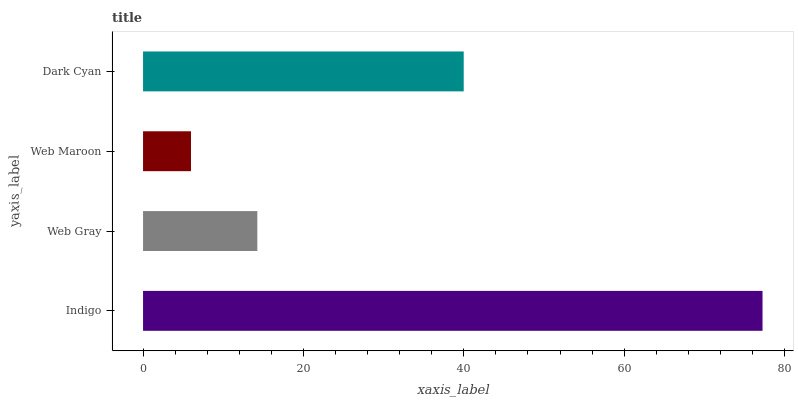Is Web Maroon the minimum?
Answer yes or no. Yes. Is Indigo the maximum?
Answer yes or no. Yes. Is Web Gray the minimum?
Answer yes or no. No. Is Web Gray the maximum?
Answer yes or no. No. Is Indigo greater than Web Gray?
Answer yes or no. Yes. Is Web Gray less than Indigo?
Answer yes or no. Yes. Is Web Gray greater than Indigo?
Answer yes or no. No. Is Indigo less than Web Gray?
Answer yes or no. No. Is Dark Cyan the high median?
Answer yes or no. Yes. Is Web Gray the low median?
Answer yes or no. Yes. Is Indigo the high median?
Answer yes or no. No. Is Indigo the low median?
Answer yes or no. No. 